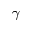Convert formula to latex. <formula><loc_0><loc_0><loc_500><loc_500>\gamma</formula> 